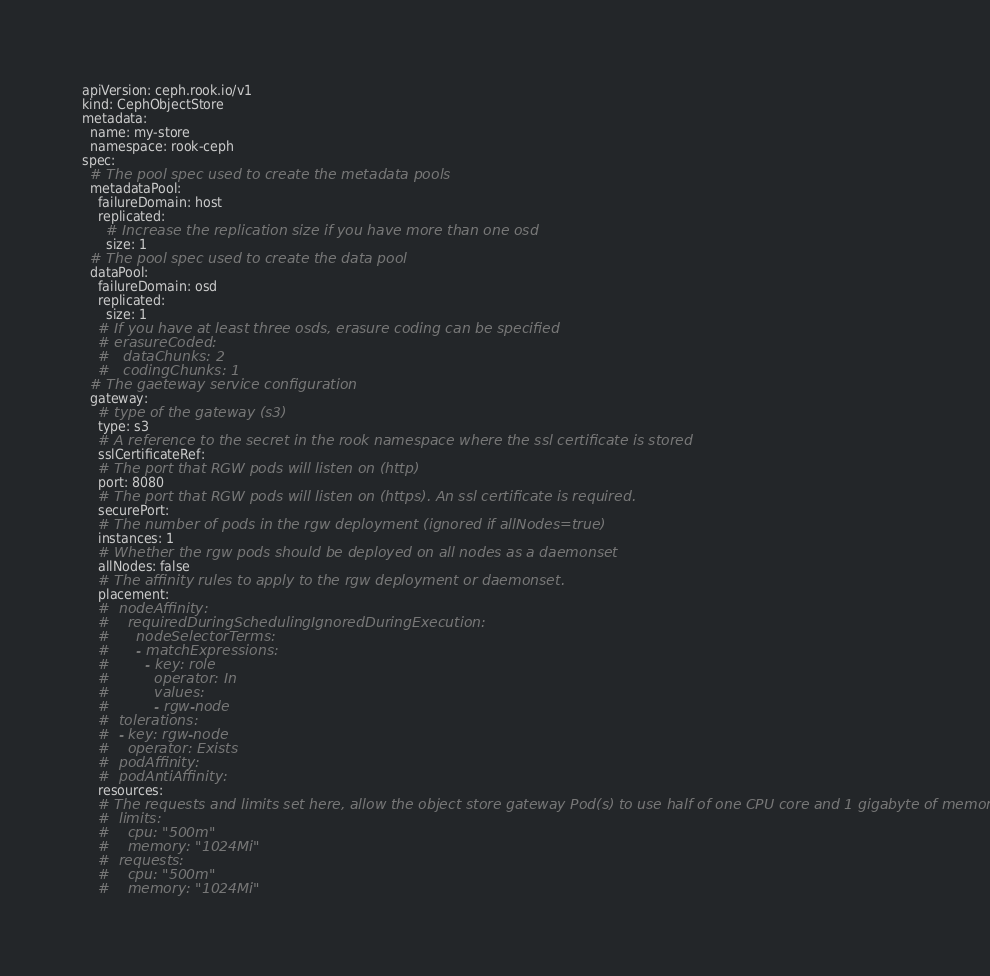Convert code to text. <code><loc_0><loc_0><loc_500><loc_500><_YAML_>apiVersion: ceph.rook.io/v1
kind: CephObjectStore
metadata:
  name: my-store
  namespace: rook-ceph
spec:
  # The pool spec used to create the metadata pools
  metadataPool:
    failureDomain: host
    replicated:
      # Increase the replication size if you have more than one osd
      size: 1
  # The pool spec used to create the data pool
  dataPool:
    failureDomain: osd
    replicated:
      size: 1
    # If you have at least three osds, erasure coding can be specified
    # erasureCoded:
    #   dataChunks: 2
    #   codingChunks: 1
  # The gaeteway service configuration
  gateway:
    # type of the gateway (s3)
    type: s3
    # A reference to the secret in the rook namespace where the ssl certificate is stored
    sslCertificateRef:
    # The port that RGW pods will listen on (http)
    port: 8080
    # The port that RGW pods will listen on (https). An ssl certificate is required.
    securePort:
    # The number of pods in the rgw deployment (ignored if allNodes=true)
    instances: 1
    # Whether the rgw pods should be deployed on all nodes as a daemonset
    allNodes: false
    # The affinity rules to apply to the rgw deployment or daemonset.
    placement:
    #  nodeAffinity:
    #    requiredDuringSchedulingIgnoredDuringExecution:
    #      nodeSelectorTerms:
    #      - matchExpressions:
    #        - key: role
    #          operator: In
    #          values:
    #          - rgw-node
    #  tolerations:
    #  - key: rgw-node
    #    operator: Exists
    #  podAffinity:
    #  podAntiAffinity:
    resources:
    # The requests and limits set here, allow the object store gateway Pod(s) to use half of one CPU core and 1 gigabyte of memory
    #  limits:
    #    cpu: "500m"
    #    memory: "1024Mi"
    #  requests:
    #    cpu: "500m"
    #    memory: "1024Mi"
</code> 